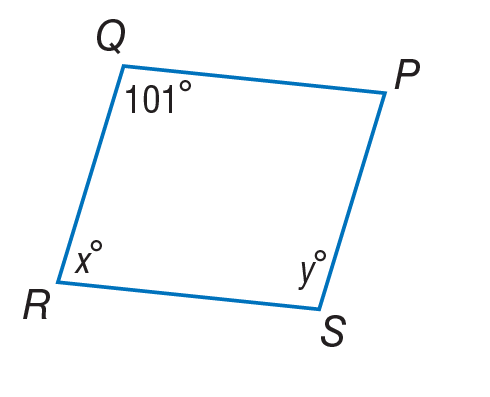Answer the mathemtical geometry problem and directly provide the correct option letter.
Question: Use parallelogram to find x.
Choices: A: 39 B: 79 C: 101 D: 180 B 